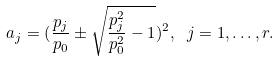Convert formula to latex. <formula><loc_0><loc_0><loc_500><loc_500>a _ { j } = ( \frac { p _ { j } } { p _ { 0 } } \pm \sqrt { \frac { p _ { j } ^ { 2 } } { p _ { 0 } ^ { 2 } } - 1 } ) ^ { 2 } , \ j = 1 , \dots , r .</formula> 